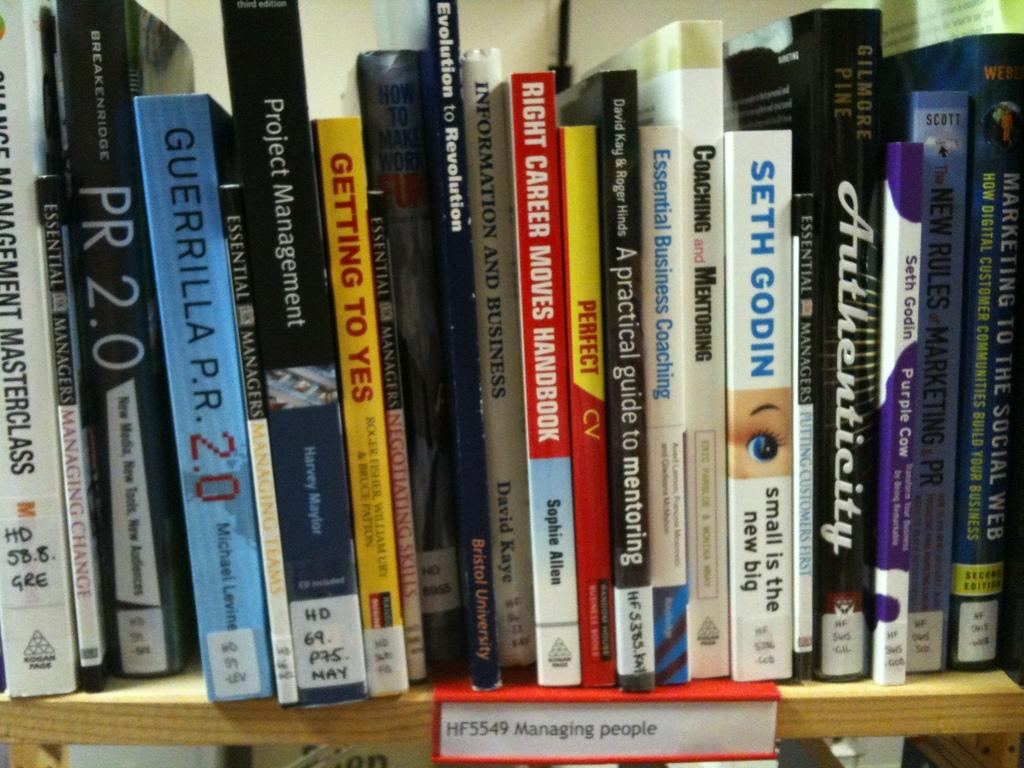<image>
Render a clear and concise summary of the photo. A stack of books with one titled Small is the New Big. 